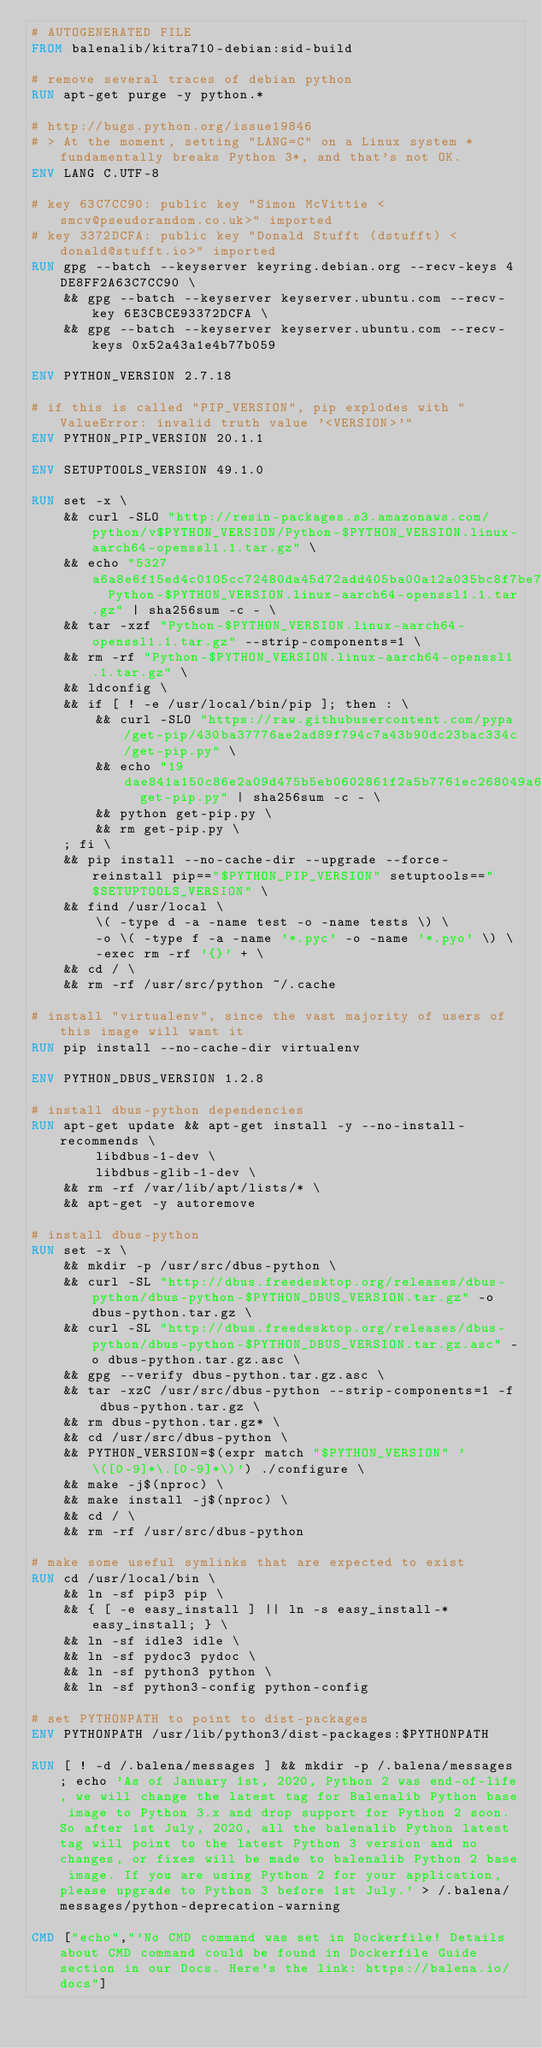<code> <loc_0><loc_0><loc_500><loc_500><_Dockerfile_># AUTOGENERATED FILE
FROM balenalib/kitra710-debian:sid-build

# remove several traces of debian python
RUN apt-get purge -y python.*

# http://bugs.python.org/issue19846
# > At the moment, setting "LANG=C" on a Linux system *fundamentally breaks Python 3*, and that's not OK.
ENV LANG C.UTF-8

# key 63C7CC90: public key "Simon McVittie <smcv@pseudorandom.co.uk>" imported
# key 3372DCFA: public key "Donald Stufft (dstufft) <donald@stufft.io>" imported
RUN gpg --batch --keyserver keyring.debian.org --recv-keys 4DE8FF2A63C7CC90 \
	&& gpg --batch --keyserver keyserver.ubuntu.com --recv-key 6E3CBCE93372DCFA \
	&& gpg --batch --keyserver keyserver.ubuntu.com --recv-keys 0x52a43a1e4b77b059

ENV PYTHON_VERSION 2.7.18

# if this is called "PIP_VERSION", pip explodes with "ValueError: invalid truth value '<VERSION>'"
ENV PYTHON_PIP_VERSION 20.1.1

ENV SETUPTOOLS_VERSION 49.1.0

RUN set -x \
	&& curl -SLO "http://resin-packages.s3.amazonaws.com/python/v$PYTHON_VERSION/Python-$PYTHON_VERSION.linux-aarch64-openssl1.1.tar.gz" \
	&& echo "5327a6a8e6f15ed4c0105cc72480da45d72add405ba00a12a035bc8f7be76ee6  Python-$PYTHON_VERSION.linux-aarch64-openssl1.1.tar.gz" | sha256sum -c - \
	&& tar -xzf "Python-$PYTHON_VERSION.linux-aarch64-openssl1.1.tar.gz" --strip-components=1 \
	&& rm -rf "Python-$PYTHON_VERSION.linux-aarch64-openssl1.1.tar.gz" \
	&& ldconfig \
	&& if [ ! -e /usr/local/bin/pip ]; then : \
		&& curl -SLO "https://raw.githubusercontent.com/pypa/get-pip/430ba37776ae2ad89f794c7a43b90dc23bac334c/get-pip.py" \
		&& echo "19dae841a150c86e2a09d475b5eb0602861f2a5b7761ec268049a662dbd2bd0c  get-pip.py" | sha256sum -c - \
		&& python get-pip.py \
		&& rm get-pip.py \
	; fi \
	&& pip install --no-cache-dir --upgrade --force-reinstall pip=="$PYTHON_PIP_VERSION" setuptools=="$SETUPTOOLS_VERSION" \
	&& find /usr/local \
		\( -type d -a -name test -o -name tests \) \
		-o \( -type f -a -name '*.pyc' -o -name '*.pyo' \) \
		-exec rm -rf '{}' + \
	&& cd / \
	&& rm -rf /usr/src/python ~/.cache

# install "virtualenv", since the vast majority of users of this image will want it
RUN pip install --no-cache-dir virtualenv

ENV PYTHON_DBUS_VERSION 1.2.8

# install dbus-python dependencies 
RUN apt-get update && apt-get install -y --no-install-recommends \
		libdbus-1-dev \
		libdbus-glib-1-dev \
	&& rm -rf /var/lib/apt/lists/* \
	&& apt-get -y autoremove

# install dbus-python
RUN set -x \
	&& mkdir -p /usr/src/dbus-python \
	&& curl -SL "http://dbus.freedesktop.org/releases/dbus-python/dbus-python-$PYTHON_DBUS_VERSION.tar.gz" -o dbus-python.tar.gz \
	&& curl -SL "http://dbus.freedesktop.org/releases/dbus-python/dbus-python-$PYTHON_DBUS_VERSION.tar.gz.asc" -o dbus-python.tar.gz.asc \
	&& gpg --verify dbus-python.tar.gz.asc \
	&& tar -xzC /usr/src/dbus-python --strip-components=1 -f dbus-python.tar.gz \
	&& rm dbus-python.tar.gz* \
	&& cd /usr/src/dbus-python \
	&& PYTHON_VERSION=$(expr match "$PYTHON_VERSION" '\([0-9]*\.[0-9]*\)') ./configure \
	&& make -j$(nproc) \
	&& make install -j$(nproc) \
	&& cd / \
	&& rm -rf /usr/src/dbus-python

# make some useful symlinks that are expected to exist
RUN cd /usr/local/bin \
	&& ln -sf pip3 pip \
	&& { [ -e easy_install ] || ln -s easy_install-* easy_install; } \
	&& ln -sf idle3 idle \
	&& ln -sf pydoc3 pydoc \
	&& ln -sf python3 python \
	&& ln -sf python3-config python-config

# set PYTHONPATH to point to dist-packages
ENV PYTHONPATH /usr/lib/python3/dist-packages:$PYTHONPATH

RUN [ ! -d /.balena/messages ] && mkdir -p /.balena/messages; echo 'As of January 1st, 2020, Python 2 was end-of-life, we will change the latest tag for Balenalib Python base image to Python 3.x and drop support for Python 2 soon. So after 1st July, 2020, all the balenalib Python latest tag will point to the latest Python 3 version and no changes, or fixes will be made to balenalib Python 2 base image. If you are using Python 2 for your application, please upgrade to Python 3 before 1st July.' > /.balena/messages/python-deprecation-warning

CMD ["echo","'No CMD command was set in Dockerfile! Details about CMD command could be found in Dockerfile Guide section in our Docs. Here's the link: https://balena.io/docs"]
</code> 